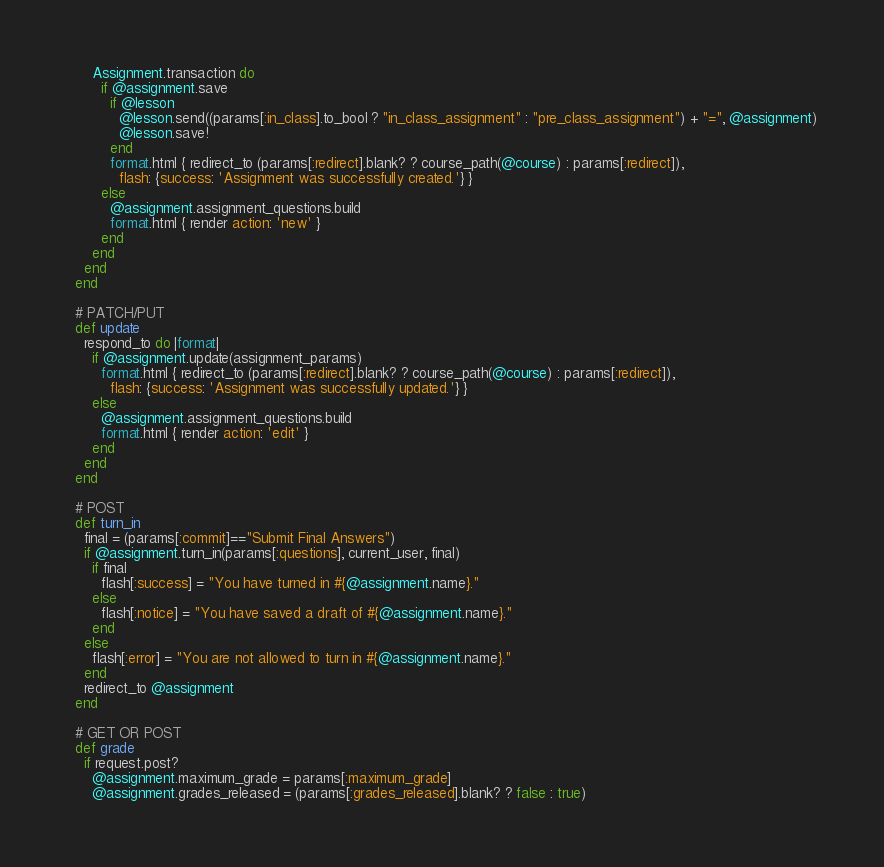<code> <loc_0><loc_0><loc_500><loc_500><_Ruby_>      Assignment.transaction do
        if @assignment.save
          if @lesson
            @lesson.send((params[:in_class].to_bool ? "in_class_assignment" : "pre_class_assignment") + "=", @assignment)
            @lesson.save!
          end
          format.html { redirect_to (params[:redirect].blank? ? course_path(@course) : params[:redirect]),
            flash: {success: 'Assignment was successfully created.'} }
        else
          @assignment.assignment_questions.build
          format.html { render action: 'new' }
        end
      end
    end
  end

  # PATCH/PUT
  def update
    respond_to do |format|
      if @assignment.update(assignment_params)
        format.html { redirect_to (params[:redirect].blank? ? course_path(@course) : params[:redirect]),
          flash: {success: 'Assignment was successfully updated.'} }
      else
        @assignment.assignment_questions.build
        format.html { render action: 'edit' }
      end
    end
  end

  # POST
  def turn_in
    final = (params[:commit]=="Submit Final Answers")
    if @assignment.turn_in(params[:questions], current_user, final)
      if final
        flash[:success] = "You have turned in #{@assignment.name}."
      else
        flash[:notice] = "You have saved a draft of #{@assignment.name}."
      end
    else
      flash[:error] = "You are not allowed to turn in #{@assignment.name}."
    end
    redirect_to @assignment
  end

  # GET OR POST
  def grade
    if request.post?
      @assignment.maximum_grade = params[:maximum_grade]
      @assignment.grades_released = (params[:grades_released].blank? ? false : true)</code> 